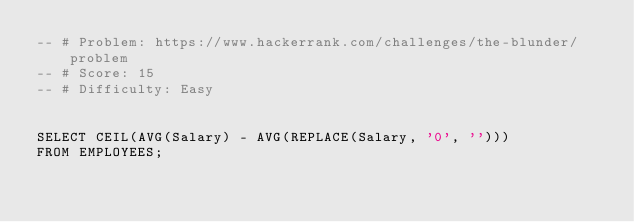Convert code to text. <code><loc_0><loc_0><loc_500><loc_500><_SQL_>-- # Problem: https://www.hackerrank.com/challenges/the-blunder/problem
-- # Score: 15
-- # Difficulty: Easy


SELECT CEIL(AVG(Salary) - AVG(REPLACE(Salary, '0', '')))
FROM EMPLOYEES;</code> 